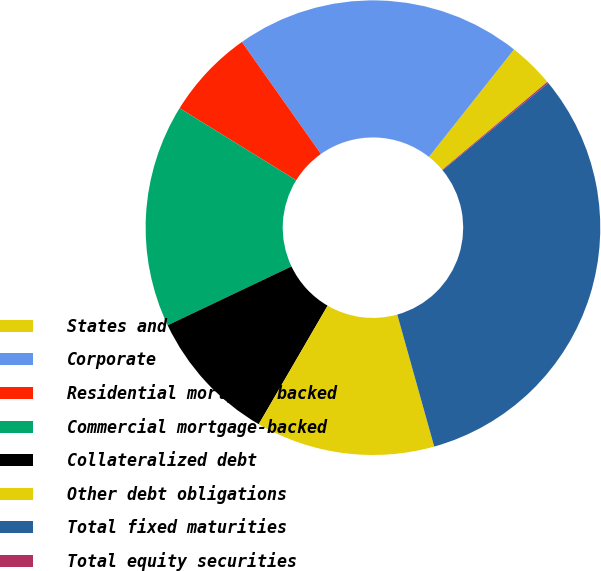Convert chart. <chart><loc_0><loc_0><loc_500><loc_500><pie_chart><fcel>States and political<fcel>Corporate<fcel>Residential mortgage-backed<fcel>Commercial mortgage-backed<fcel>Collateralized debt<fcel>Other debt obligations<fcel>Total fixed maturities<fcel>Total equity securities<nl><fcel>3.26%<fcel>20.44%<fcel>6.41%<fcel>15.87%<fcel>9.56%<fcel>12.72%<fcel>31.64%<fcel>0.1%<nl></chart> 